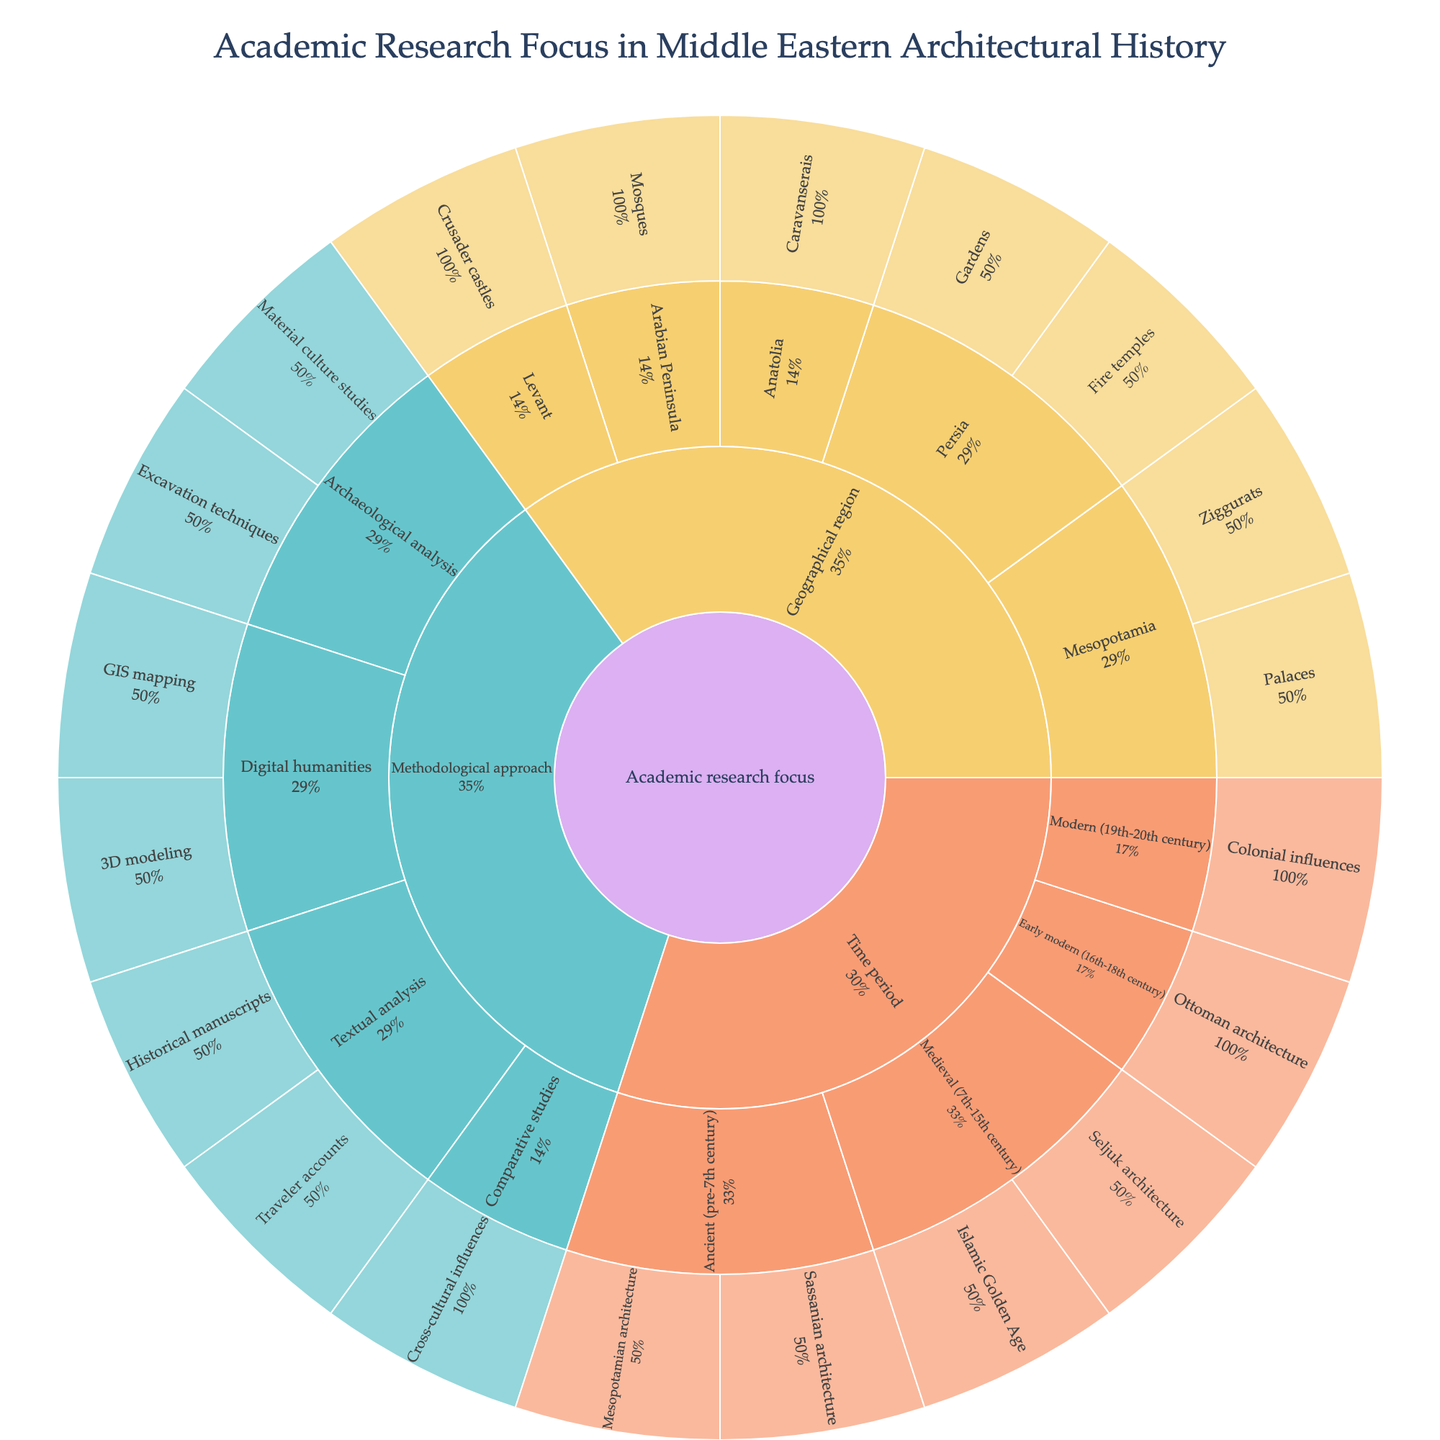What is the title of the sunburst plot? The title of any graphical representation is usually placed at the top center. It summarizes what the data plot represents, which in this case is "Academic Research Focus in Middle Eastern Architectural History".
Answer: Academic Research Focus in Middle Eastern Architectural History How many main categories are presented in the outermost layer of the sunburst plot? The outermost layer of a sunburst plot shows distinct segments branching from the center. Here, there are three main categories: Time period, Geographical region, and Methodological approach.
Answer: Three Which methodological approach has the largest number of subcategories? By examining the methodological approach section and counting the different subcategories branching out, it's evident that Archaeological analysis and Textual analysis each have two subcategories, but digital humanities with GIS mapping and 3D modeling has the largest number.
Answer: Digital humanities Under the Time period category, which focus area is related to the Medieval (7th-15th century) period? Within the 'Time period' slice of the sunburst, look for the branch labeled 'Medieval (7th-15th century)' and examine its subdivisions. The focus areas are Islamic Golden Age and Seljuk architecture.
Answer: Islamic Golden Age, Seljuk architecture In terms of geographical regions, what specific architectural study is linked to Mesopotamia? Follow the 'Geographical region' segment and identify 'Mesopotamia'. The specific architectural studies include Ziggurats and Palaces.
Answer: Ziggurats, Palaces Compare the number of subcategories under 'Time period' and 'Methodological approach'. Which has more subcategories and by how many? Count the subcategories under each main branch. 'Time period' has five subcategories, and 'Methodological approach' has six subcategories. Thus, 'Methodological approach' has one more subcategory than 'Time period'.
Answer: Methodological approach, 1 What percentage of the 'Geographical region' category is focused on Persia? Look at the portion of the sunburst dedicated to the 'Geographical region' and observe the Persia section. Persia has two subcategories (Fire temples and Gardens) within its segment, and judging the visual proportion, it appears to cover 2 out of the 7 possible subcategories in 'Geographical region'. The visual segment labeled can be roughly estimated.
Answer: 28.6% Which time period is associated with Ottoman architecture? Within the 'Time period' segment of the sunburst, track the branches till you find the one labeled 'Ottoman architecture'. It is linked under 'Early modern (16th-18th century)'.
Answer: Early modern (16th-18th century) What are the subcategories under 'Textual analysis' within the methodological approach? Under the 'Methodological approach' category, locate the 'Textual analysis' branch and identify its subcategories. They are Historical manuscripts and Traveler accounts.
Answer: Historical manuscripts, Traveler accounts 